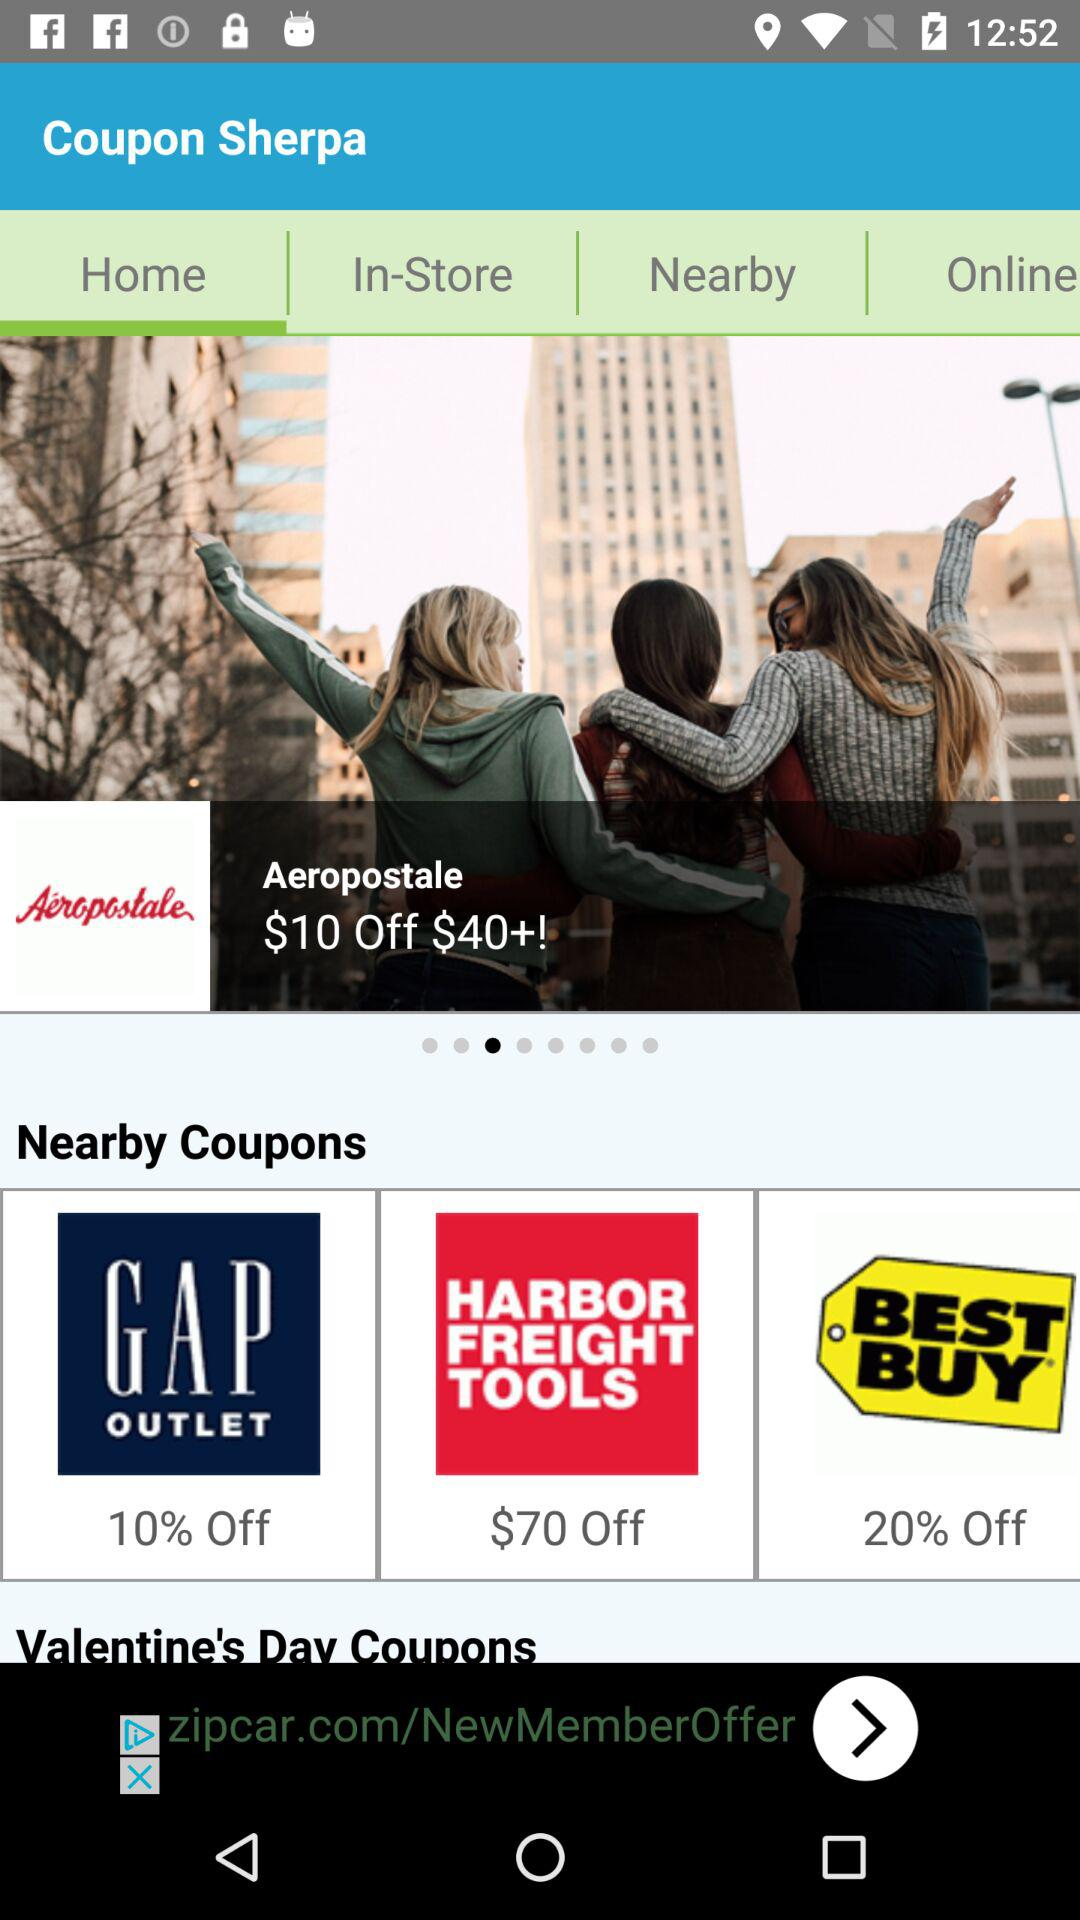How much of the percentage is off on "Aeropostale"? The percentage off on "Aeropostale" is $10. 